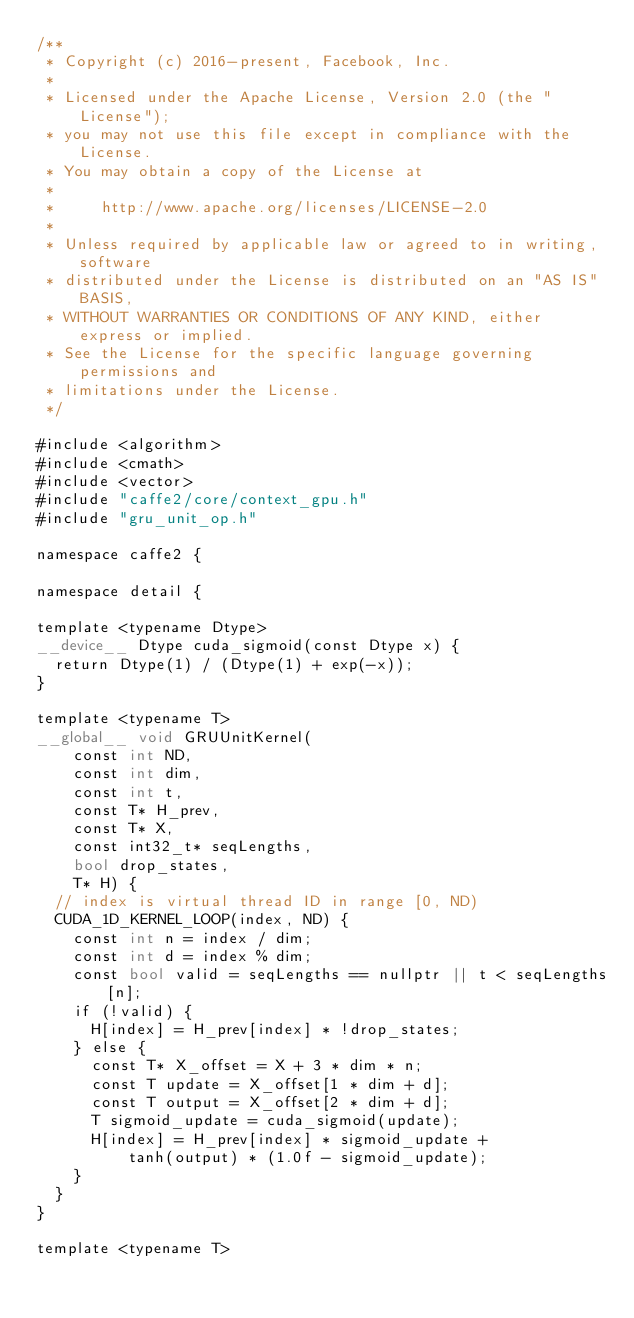Convert code to text. <code><loc_0><loc_0><loc_500><loc_500><_Cuda_>/**
 * Copyright (c) 2016-present, Facebook, Inc.
 *
 * Licensed under the Apache License, Version 2.0 (the "License");
 * you may not use this file except in compliance with the License.
 * You may obtain a copy of the License at
 *
 *     http://www.apache.org/licenses/LICENSE-2.0
 *
 * Unless required by applicable law or agreed to in writing, software
 * distributed under the License is distributed on an "AS IS" BASIS,
 * WITHOUT WARRANTIES OR CONDITIONS OF ANY KIND, either express or implied.
 * See the License for the specific language governing permissions and
 * limitations under the License.
 */

#include <algorithm>
#include <cmath>
#include <vector>
#include "caffe2/core/context_gpu.h"
#include "gru_unit_op.h"

namespace caffe2 {

namespace detail {

template <typename Dtype>
__device__ Dtype cuda_sigmoid(const Dtype x) {
  return Dtype(1) / (Dtype(1) + exp(-x));
}

template <typename T>
__global__ void GRUUnitKernel(
    const int ND,
    const int dim,
    const int t,
    const T* H_prev,
    const T* X,
    const int32_t* seqLengths,
    bool drop_states,
    T* H) {
  // index is virtual thread ID in range [0, ND)
  CUDA_1D_KERNEL_LOOP(index, ND) {
    const int n = index / dim;
    const int d = index % dim;
    const bool valid = seqLengths == nullptr || t < seqLengths[n];
    if (!valid) {
      H[index] = H_prev[index] * !drop_states;
    } else {
      const T* X_offset = X + 3 * dim * n;
      const T update = X_offset[1 * dim + d];
      const T output = X_offset[2 * dim + d];
      T sigmoid_update = cuda_sigmoid(update);
      H[index] = H_prev[index] * sigmoid_update +
          tanh(output) * (1.0f - sigmoid_update);
    }
  }
}

template <typename T></code> 